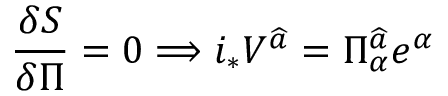<formula> <loc_0><loc_0><loc_500><loc_500>\frac { \delta S } { \delta \Pi } = 0 \Longrightarrow i _ { * } V ^ { \widehat { a } } = \Pi _ { \alpha } ^ { \widehat { a } } e ^ { \alpha }</formula> 